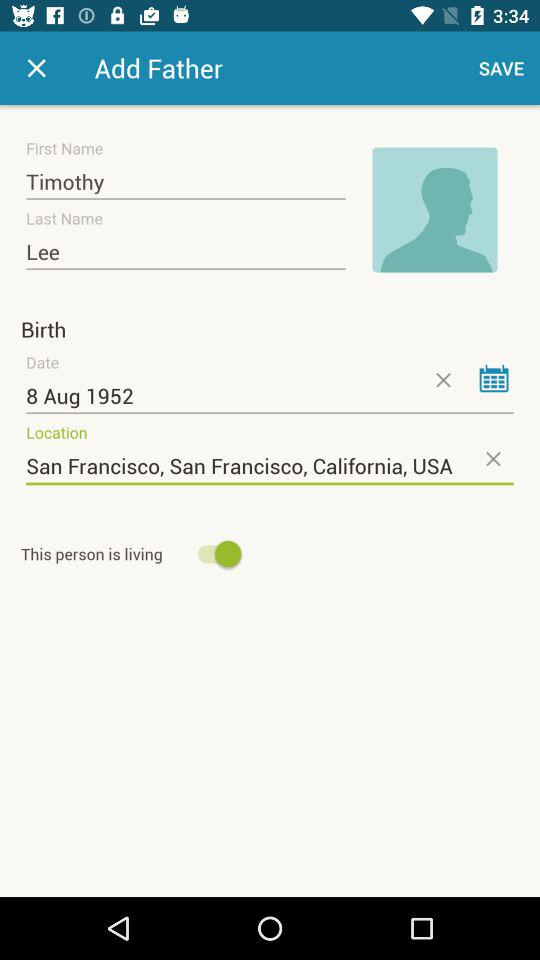What is the first name of the user? The first name of the user is Timothy. 